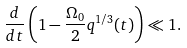Convert formula to latex. <formula><loc_0><loc_0><loc_500><loc_500>\frac { d } { d t } \left ( 1 - \frac { \Omega _ { 0 } } { 2 } q ^ { 1 / 3 } ( t ) \right ) \ll 1 .</formula> 